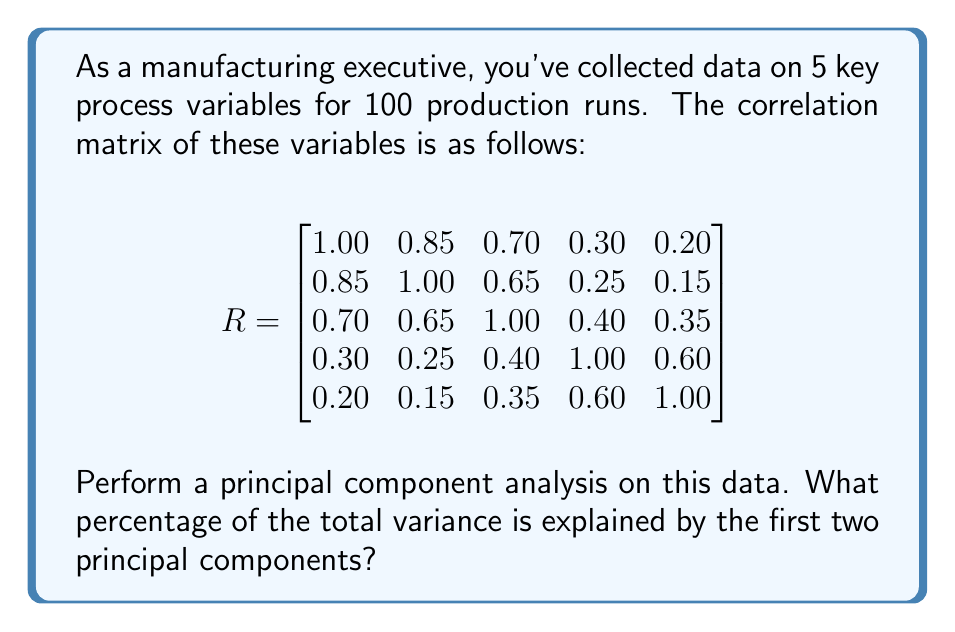Help me with this question. To perform principal component analysis and determine the percentage of variance explained by the first two principal components, we need to follow these steps:

1. Calculate the eigenvalues and eigenvectors of the correlation matrix.
2. Sort the eigenvalues in descending order.
3. Calculate the proportion of variance explained by each principal component.
4. Sum the proportions for the first two components.

Step 1: Calculate eigenvalues and eigenvectors
Using a numerical method or software, we find the eigenvalues of the correlation matrix:

$$\lambda_1 = 2.8954, \lambda_2 = 1.2641, \lambda_3 = 0.4872, \lambda_4 = 0.2298, \lambda_5 = 0.1235$$

Step 2: Sort eigenvalues
The eigenvalues are already sorted in descending order.

Step 3: Calculate proportion of variance explained
The total variance is the sum of all eigenvalues, which equals the number of variables (5 in this case) for a correlation matrix.

For each principal component, the proportion of variance explained is:

$$\text{Proportion}_i = \frac{\lambda_i}{\sum_{j=1}^5 \lambda_j} = \frac{\lambda_i}{5}$$

For the first two components:

$$\text{Proportion}_1 = \frac{2.8954}{5} = 0.5791 \text{ or } 57.91\%$$
$$\text{Proportion}_2 = \frac{1.2641}{5} = 0.2528 \text{ or } 25.28\%$$

Step 4: Sum the proportions
The total proportion of variance explained by the first two principal components is:

$$0.5791 + 0.2528 = 0.8319 \text{ or } 83.19\%$$

Therefore, the first two principal components explain 83.19% of the total variance in the manufacturing process data.
Answer: 83.19% 